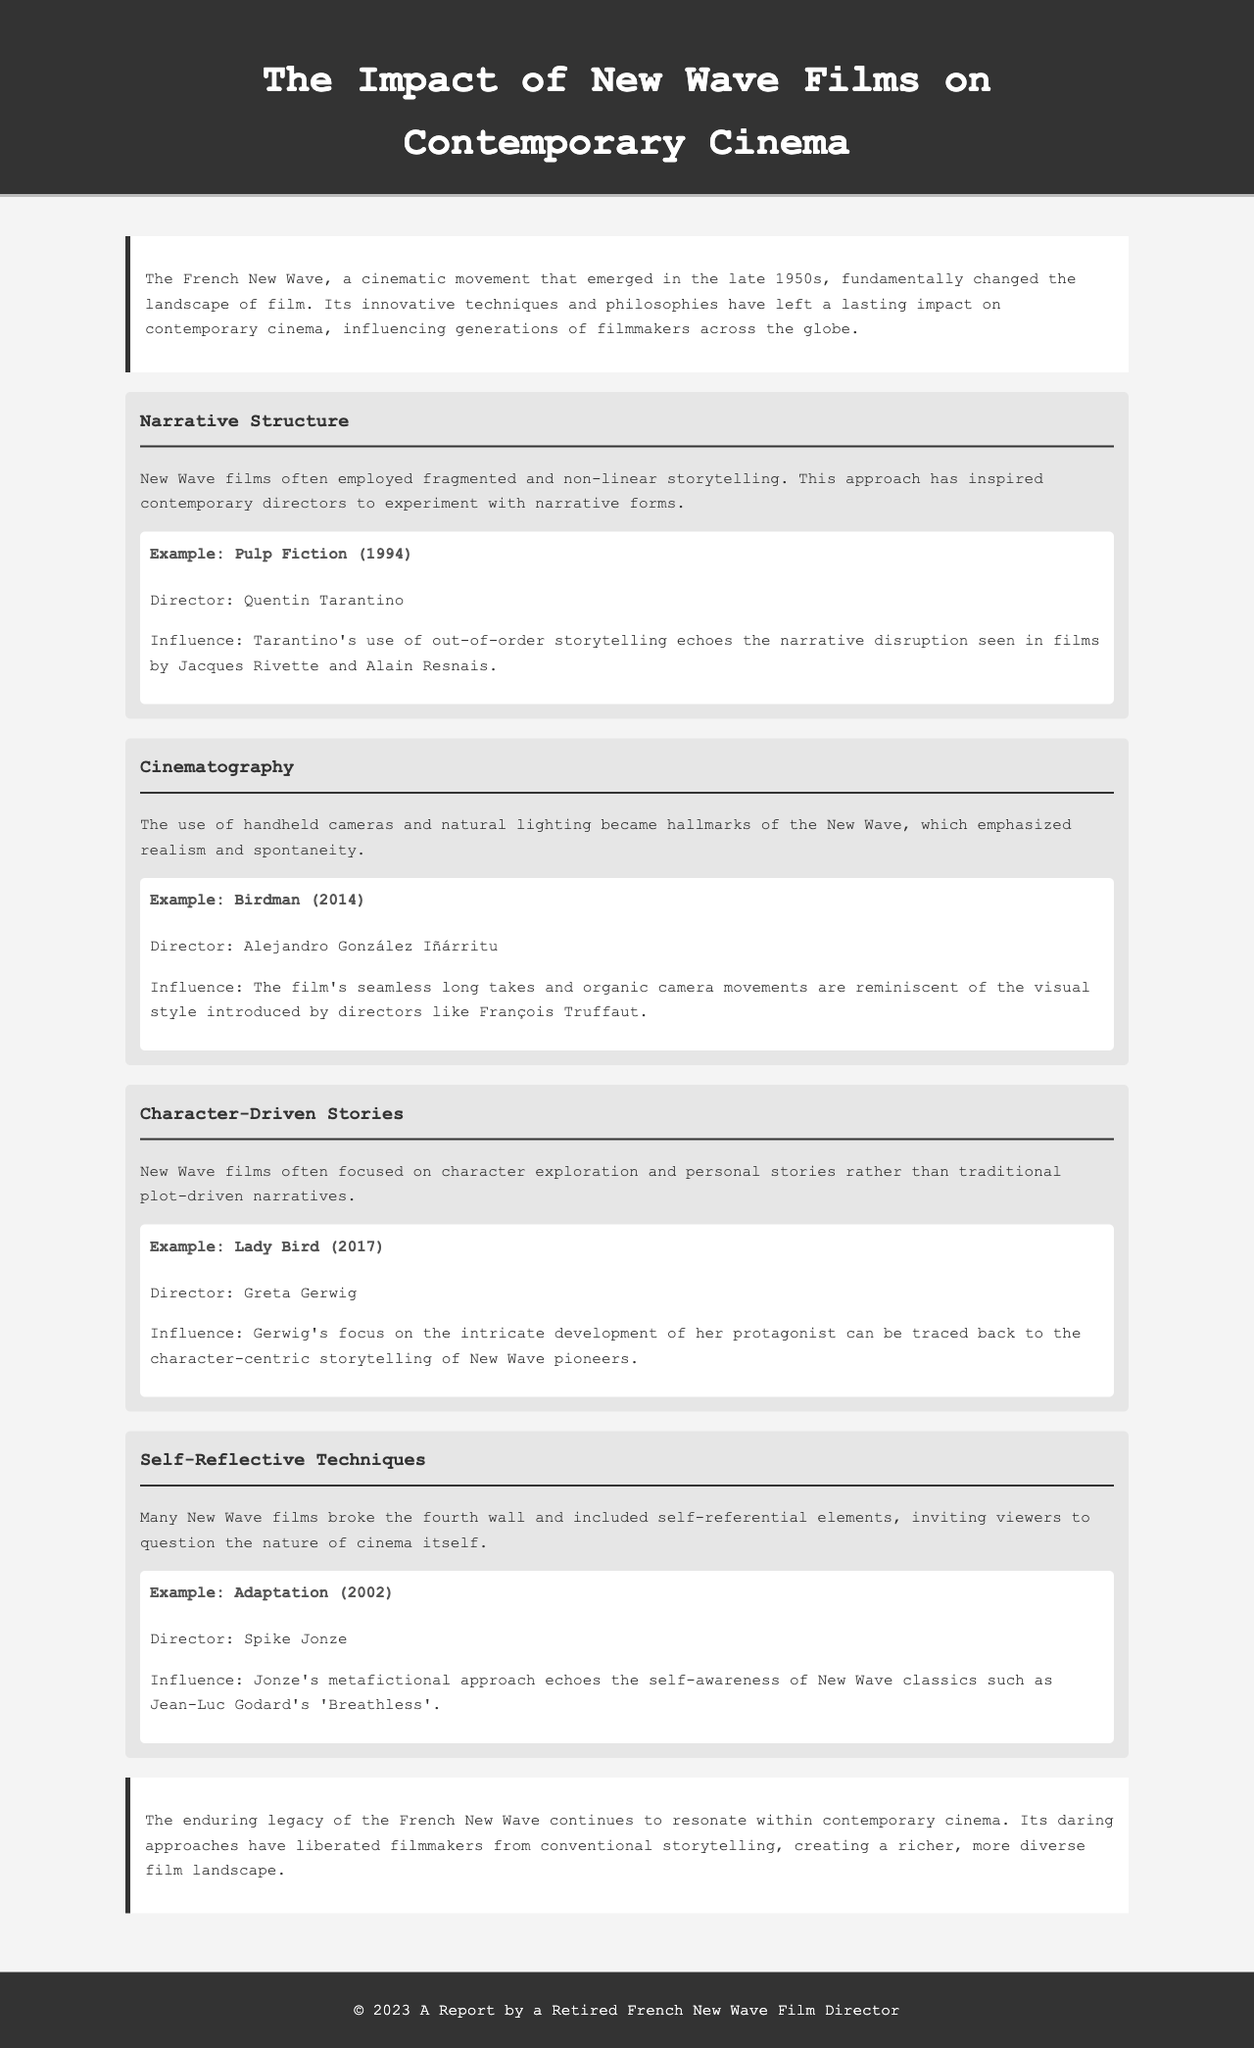What is the main focus of the French New Wave? The document states that the French New Wave fundamentally changed the landscape of film through innovative techniques and philosophies.
Answer: Innovative techniques and philosophies Which film is cited for its non-linear storytelling influence? The example provided for non-linear storytelling is 'Pulp Fiction,' directed by Quentin Tarantino.
Answer: Pulp Fiction Who directed 'Birdman'? The document mentions Alejandro González Iñárritu as the director of 'Birdman.'
Answer: Alejandro González Iñárritu What is a hallmark of New Wave cinematography? The document highlights the use of handheld cameras and natural lighting as hallmarks of New Wave cinematography.
Answer: Handheld cameras and natural lighting Which contemporary film emphasizes character exploration similar to New Wave films? 'Lady Bird,' directed by Greta Gerwig, focuses on character exploration akin to New Wave storytelling.
Answer: Lady Bird How did New Wave films impact character-driven stories? The document explains that New Wave films focused on character exploration and personal stories over traditional plot-driven narratives.
Answer: Character exploration and personal stories What self-reflective technique is noted in 'Adaptation'? 'Adaptation' employs a metafictional approach, as mentioned in the document.
Answer: Metafictional approach What is the legacy of the French New Wave according to the conclusion? The conclusion states that the French New Wave's legacy continues to resonate and liberate filmmakers from conventional storytelling.
Answer: Liberated filmmakers from conventional storytelling Which director is associated with the film 'Breathless'? Jean-Luc Godard is the director associated with the film 'Breathless.'
Answer: Jean-Luc Godard 